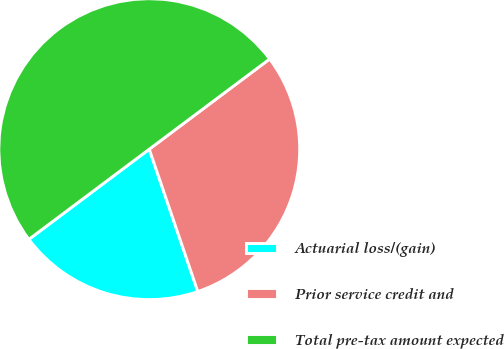<chart> <loc_0><loc_0><loc_500><loc_500><pie_chart><fcel>Actuarial loss/(gain)<fcel>Prior service credit and<fcel>Total pre-tax amount expected<nl><fcel>20.0%<fcel>30.0%<fcel>50.0%<nl></chart> 